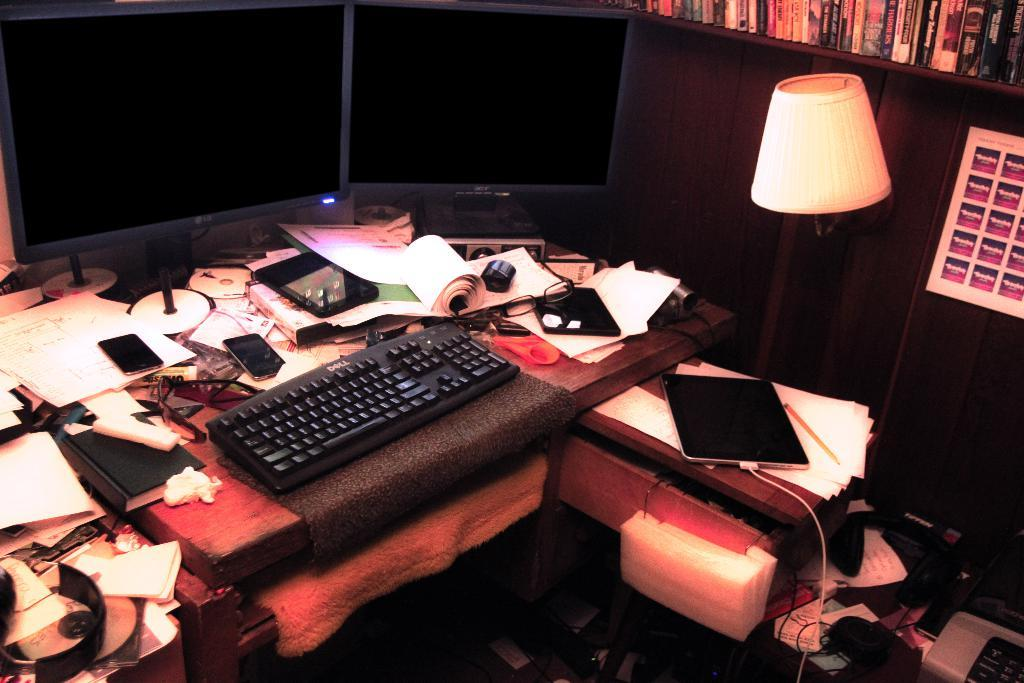What is the main piece of furniture in the image? There is a table in the image. What is covering the table? There is a cloth on the table. What electronic device is on the table? There is a keyboard on the table. What other object is on the table? There is a mobile on the table. What type of stationery item is on the table? There are papers on the table. What light source is in the image? There is a lamp in the image. Where are the books located in the image? There are books in a rack in the image. What is the condition of the garden in the image? There is no garden present in the image. Can you tell me what your dad is doing in the image? There is no person, including a dad, present in the image. 